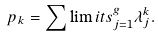Convert formula to latex. <formula><loc_0><loc_0><loc_500><loc_500>p _ { k } = \sum \lim i t s _ { j = 1 } ^ { g } \lambda _ { j } ^ { k } .</formula> 